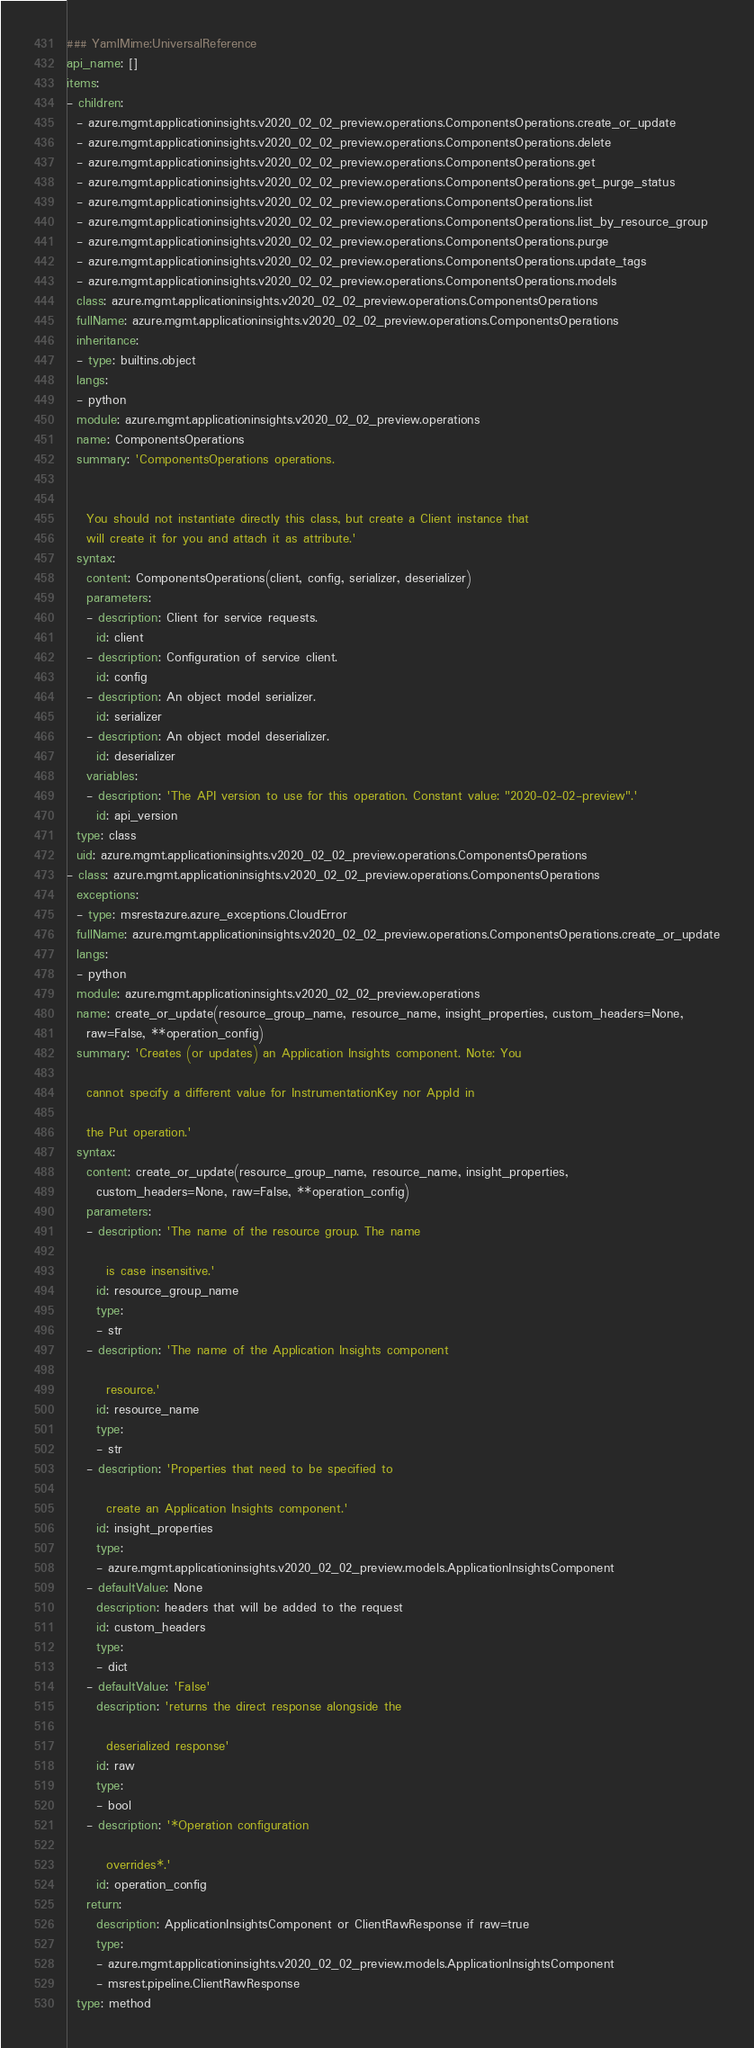<code> <loc_0><loc_0><loc_500><loc_500><_YAML_>### YamlMime:UniversalReference
api_name: []
items:
- children:
  - azure.mgmt.applicationinsights.v2020_02_02_preview.operations.ComponentsOperations.create_or_update
  - azure.mgmt.applicationinsights.v2020_02_02_preview.operations.ComponentsOperations.delete
  - azure.mgmt.applicationinsights.v2020_02_02_preview.operations.ComponentsOperations.get
  - azure.mgmt.applicationinsights.v2020_02_02_preview.operations.ComponentsOperations.get_purge_status
  - azure.mgmt.applicationinsights.v2020_02_02_preview.operations.ComponentsOperations.list
  - azure.mgmt.applicationinsights.v2020_02_02_preview.operations.ComponentsOperations.list_by_resource_group
  - azure.mgmt.applicationinsights.v2020_02_02_preview.operations.ComponentsOperations.purge
  - azure.mgmt.applicationinsights.v2020_02_02_preview.operations.ComponentsOperations.update_tags
  - azure.mgmt.applicationinsights.v2020_02_02_preview.operations.ComponentsOperations.models
  class: azure.mgmt.applicationinsights.v2020_02_02_preview.operations.ComponentsOperations
  fullName: azure.mgmt.applicationinsights.v2020_02_02_preview.operations.ComponentsOperations
  inheritance:
  - type: builtins.object
  langs:
  - python
  module: azure.mgmt.applicationinsights.v2020_02_02_preview.operations
  name: ComponentsOperations
  summary: 'ComponentsOperations operations.


    You should not instantiate directly this class, but create a Client instance that
    will create it for you and attach it as attribute.'
  syntax:
    content: ComponentsOperations(client, config, serializer, deserializer)
    parameters:
    - description: Client for service requests.
      id: client
    - description: Configuration of service client.
      id: config
    - description: An object model serializer.
      id: serializer
    - description: An object model deserializer.
      id: deserializer
    variables:
    - description: 'The API version to use for this operation. Constant value: "2020-02-02-preview".'
      id: api_version
  type: class
  uid: azure.mgmt.applicationinsights.v2020_02_02_preview.operations.ComponentsOperations
- class: azure.mgmt.applicationinsights.v2020_02_02_preview.operations.ComponentsOperations
  exceptions:
  - type: msrestazure.azure_exceptions.CloudError
  fullName: azure.mgmt.applicationinsights.v2020_02_02_preview.operations.ComponentsOperations.create_or_update
  langs:
  - python
  module: azure.mgmt.applicationinsights.v2020_02_02_preview.operations
  name: create_or_update(resource_group_name, resource_name, insight_properties, custom_headers=None,
    raw=False, **operation_config)
  summary: 'Creates (or updates) an Application Insights component. Note: You

    cannot specify a different value for InstrumentationKey nor AppId in

    the Put operation.'
  syntax:
    content: create_or_update(resource_group_name, resource_name, insight_properties,
      custom_headers=None, raw=False, **operation_config)
    parameters:
    - description: 'The name of the resource group. The name

        is case insensitive.'
      id: resource_group_name
      type:
      - str
    - description: 'The name of the Application Insights component

        resource.'
      id: resource_name
      type:
      - str
    - description: 'Properties that need to be specified to

        create an Application Insights component.'
      id: insight_properties
      type:
      - azure.mgmt.applicationinsights.v2020_02_02_preview.models.ApplicationInsightsComponent
    - defaultValue: None
      description: headers that will be added to the request
      id: custom_headers
      type:
      - dict
    - defaultValue: 'False'
      description: 'returns the direct response alongside the

        deserialized response'
      id: raw
      type:
      - bool
    - description: '*Operation configuration

        overrides*.'
      id: operation_config
    return:
      description: ApplicationInsightsComponent or ClientRawResponse if raw=true
      type:
      - azure.mgmt.applicationinsights.v2020_02_02_preview.models.ApplicationInsightsComponent
      - msrest.pipeline.ClientRawResponse
  type: method</code> 